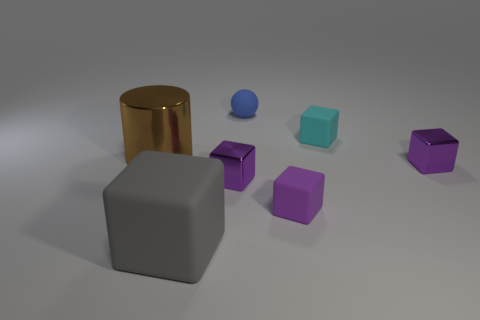Subtract all gray spheres. How many purple cubes are left? 3 Subtract all cyan blocks. How many blocks are left? 4 Subtract 1 cubes. How many cubes are left? 4 Subtract all big rubber blocks. How many blocks are left? 4 Subtract all brown blocks. Subtract all green cylinders. How many blocks are left? 5 Add 2 small gray things. How many objects exist? 9 Subtract all balls. How many objects are left? 6 Add 1 small spheres. How many small spheres are left? 2 Add 4 tiny things. How many tiny things exist? 9 Subtract 1 brown cylinders. How many objects are left? 6 